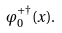<formula> <loc_0><loc_0><loc_500><loc_500>\varphi _ { 0 } ^ { + \dagger } ( x ) .</formula> 